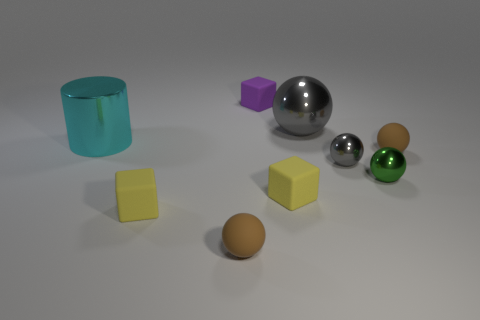What material is the tiny block that is left of the purple block?
Make the answer very short. Rubber. How many objects are brown spheres behind the tiny gray thing or tiny cyan balls?
Offer a very short reply. 1. Are there the same number of gray metal spheres that are on the right side of the small green ball and tiny blue shiny balls?
Give a very brief answer. Yes. Do the shiny cylinder and the purple object have the same size?
Offer a terse response. No. What is the color of the other metallic ball that is the same size as the green metallic ball?
Your response must be concise. Gray. Do the cyan cylinder and the metal sphere that is in front of the tiny gray metallic ball have the same size?
Provide a succinct answer. No. What number of other metal spheres have the same color as the large shiny ball?
Offer a terse response. 1. How many things are either large green rubber things or rubber objects that are in front of the large cyan metal cylinder?
Your answer should be compact. 4. There is a gray metal object behind the large cyan shiny cylinder; does it have the same size as the metal thing that is to the left of the purple object?
Offer a very short reply. Yes. Are there any other objects that have the same material as the purple thing?
Provide a succinct answer. Yes. 